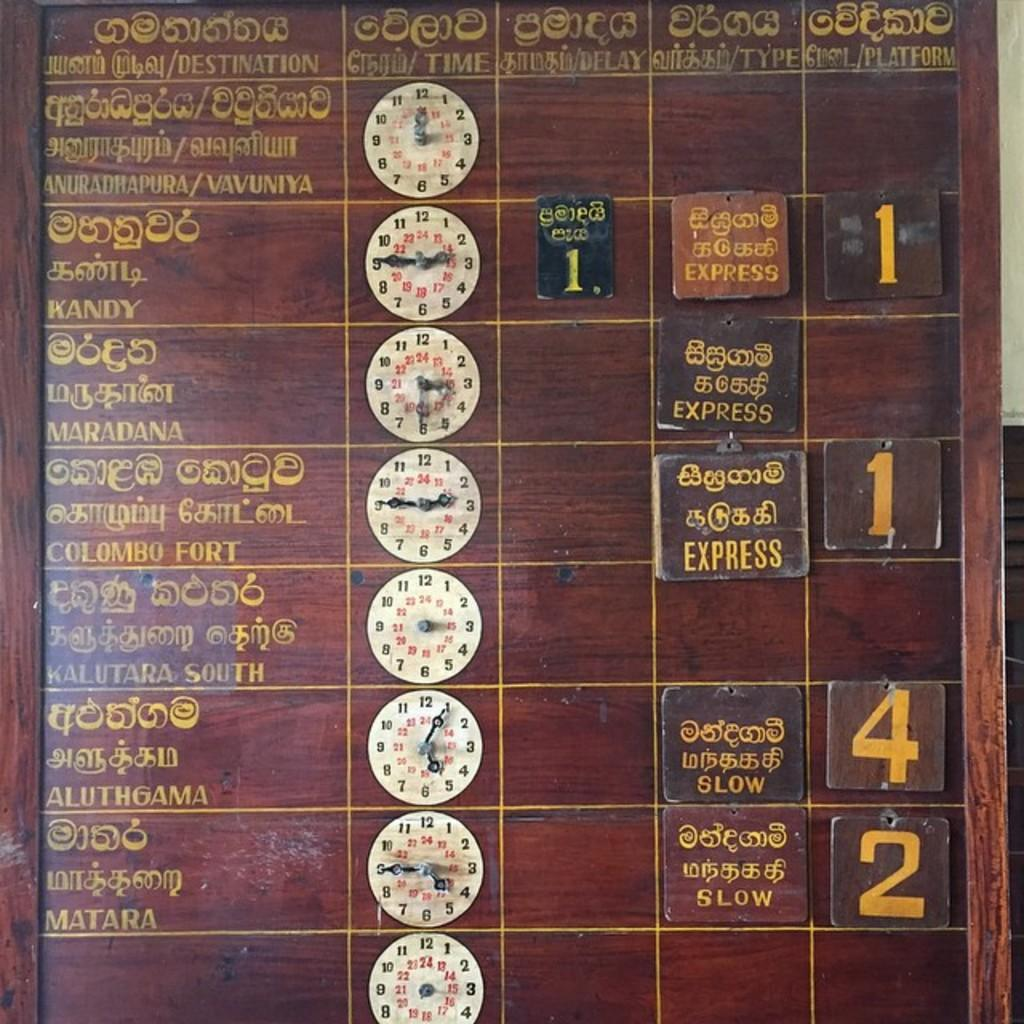Where was the image taken? The image was taken indoors. What can be seen on the right side of the image? There is a wall on the right side of the image. What is the main object in the middle of the image? There is a board with text in the middle of the image. What type of objects are on the board? There are clocks on the board. What type of clover is growing on the linen in the image? There is no clover or linen present in the image. Can you tell me how many parents are visible in the image? There are no parents visible in the image. 